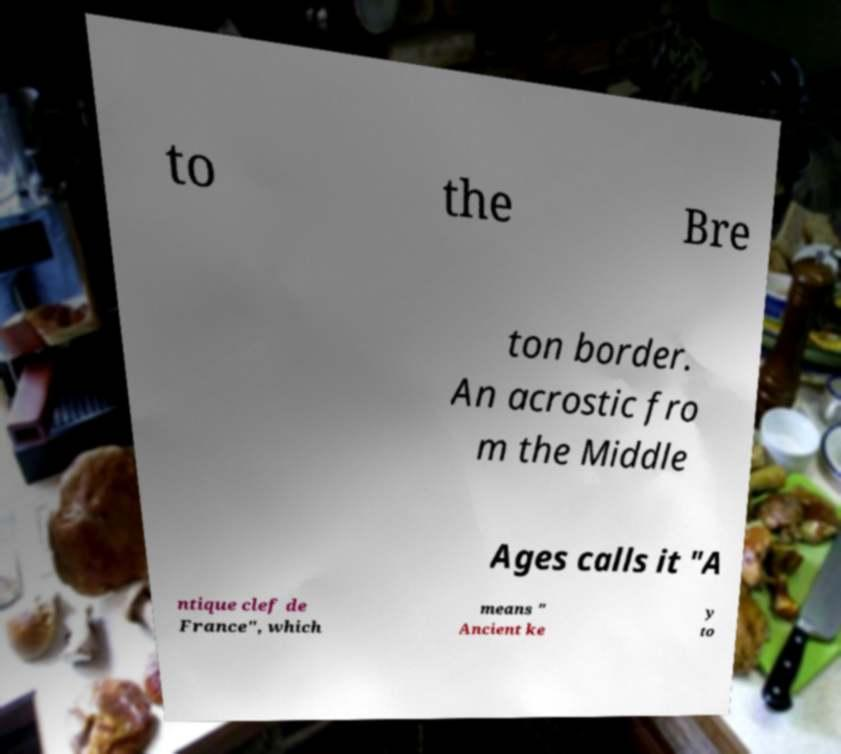Please identify and transcribe the text found in this image. to the Bre ton border. An acrostic fro m the Middle Ages calls it "A ntique clef de France", which means " Ancient ke y to 